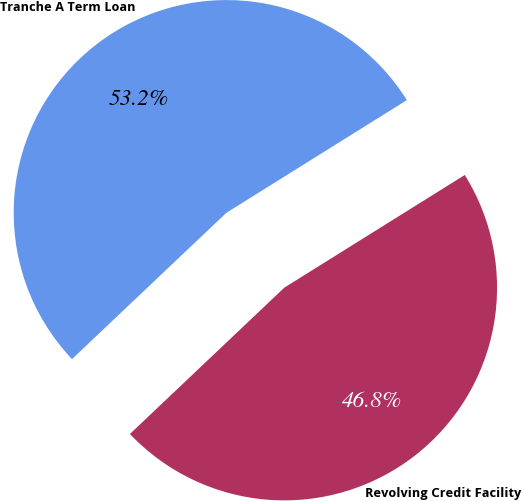<chart> <loc_0><loc_0><loc_500><loc_500><pie_chart><fcel>Revolving Credit Facility<fcel>Tranche A Term Loan<nl><fcel>46.81%<fcel>53.19%<nl></chart> 